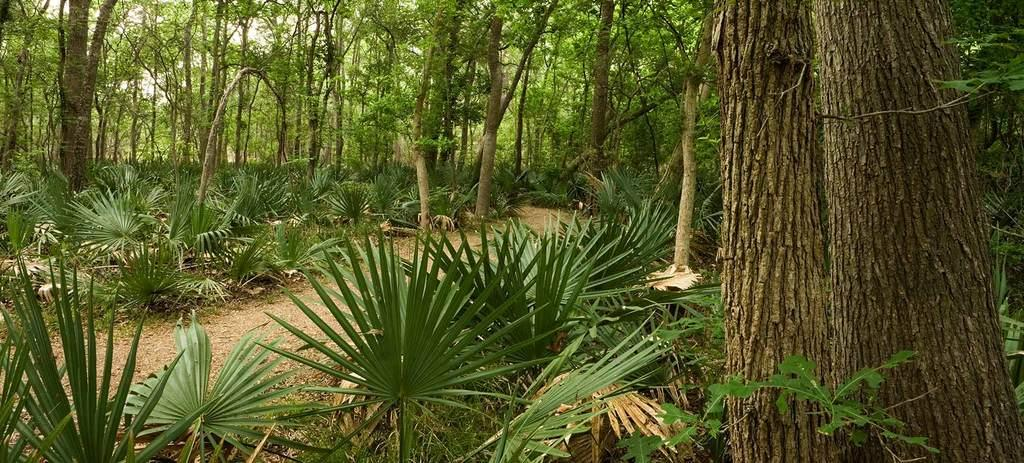What type of environment is depicted in the image? The image appears to depict a forest. What can be seen on the left side of the image? There is a path on the left side of the image. What is present on both sides of the path? Many plants are present on both sides of the path. What is visible in the background of the image? There are many trees visible in the background of the image. What type of education can be seen taking place in the image? There is no indication of any educational activity taking place in the image; it depicts a forest with a path and plants. Can you see a nest in the image? There is no nest visible in the image. 